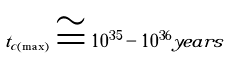<formula> <loc_0><loc_0><loc_500><loc_500>t _ { c ( \max ) } \cong 1 0 ^ { 3 5 } - 1 0 ^ { 3 6 } y e a r s</formula> 